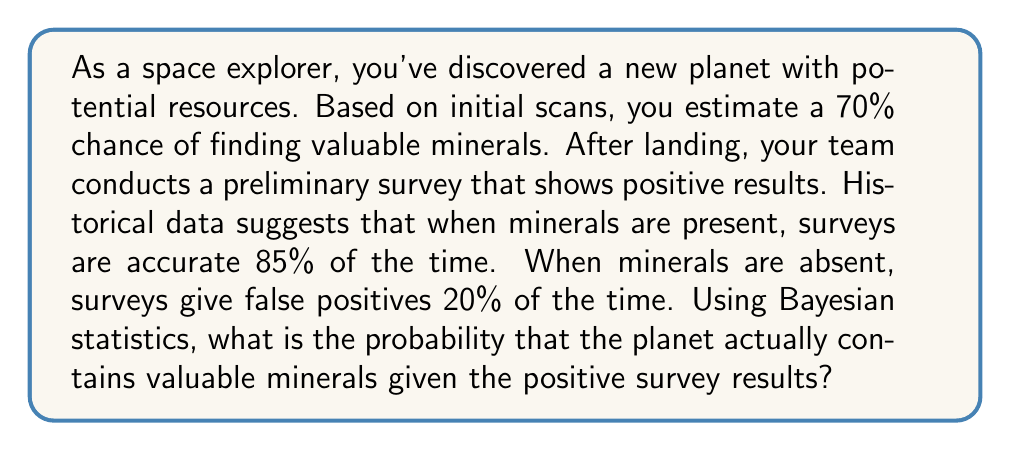Provide a solution to this math problem. Let's approach this problem using Bayesian statistics:

1. Define our events:
   A: The planet contains valuable minerals
   B: The survey shows positive results

2. Given probabilities:
   P(A) = 0.70 (prior probability of minerals)
   P(B|A) = 0.85 (true positive rate)
   P(B|not A) = 0.20 (false positive rate)

3. We want to find P(A|B) using Bayes' theorem:

   $$P(A|B) = \frac{P(B|A) \cdot P(A)}{P(B)}$$

4. Calculate P(B) using the law of total probability:
   $$P(B) = P(B|A) \cdot P(A) + P(B|not A) \cdot P(not A)$$
   $$P(B) = 0.85 \cdot 0.70 + 0.20 \cdot 0.30$$
   $$P(B) = 0.595 + 0.06 = 0.655$$

5. Now we can apply Bayes' theorem:

   $$P(A|B) = \frac{0.85 \cdot 0.70}{0.655} = \frac{0.595}{0.655} \approx 0.9084$$

6. Convert to a percentage: 0.9084 * 100% ≈ 90.84%

Therefore, given the positive survey results, there is approximately a 90.84% chance that the planet actually contains valuable minerals.
Answer: 90.84% 